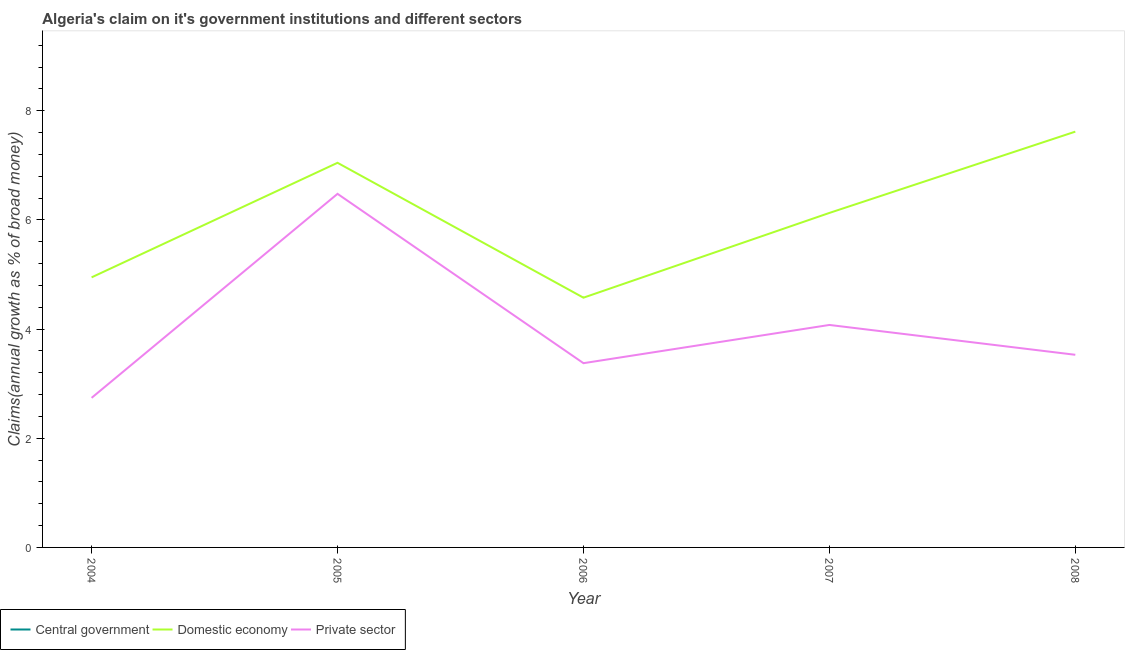How many different coloured lines are there?
Your answer should be very brief. 2. What is the percentage of claim on the domestic economy in 2008?
Offer a terse response. 7.62. Across all years, what is the maximum percentage of claim on the domestic economy?
Your answer should be compact. 7.62. Across all years, what is the minimum percentage of claim on the private sector?
Your answer should be very brief. 2.74. What is the total percentage of claim on the central government in the graph?
Ensure brevity in your answer.  0. What is the difference between the percentage of claim on the private sector in 2006 and that in 2008?
Give a very brief answer. -0.15. What is the difference between the percentage of claim on the central government in 2004 and the percentage of claim on the domestic economy in 2005?
Your response must be concise. -7.05. What is the average percentage of claim on the private sector per year?
Make the answer very short. 4.04. In the year 2007, what is the difference between the percentage of claim on the private sector and percentage of claim on the domestic economy?
Your answer should be very brief. -2.05. In how many years, is the percentage of claim on the domestic economy greater than 6 %?
Your response must be concise. 3. What is the ratio of the percentage of claim on the private sector in 2004 to that in 2005?
Offer a very short reply. 0.42. What is the difference between the highest and the second highest percentage of claim on the domestic economy?
Provide a short and direct response. 0.57. What is the difference between the highest and the lowest percentage of claim on the private sector?
Offer a very short reply. 3.74. In how many years, is the percentage of claim on the private sector greater than the average percentage of claim on the private sector taken over all years?
Make the answer very short. 2. Is the sum of the percentage of claim on the private sector in 2006 and 2008 greater than the maximum percentage of claim on the domestic economy across all years?
Provide a short and direct response. No. Is it the case that in every year, the sum of the percentage of claim on the central government and percentage of claim on the domestic economy is greater than the percentage of claim on the private sector?
Give a very brief answer. Yes. Is the percentage of claim on the domestic economy strictly greater than the percentage of claim on the private sector over the years?
Give a very brief answer. Yes. Are the values on the major ticks of Y-axis written in scientific E-notation?
Offer a terse response. No. Does the graph contain any zero values?
Provide a succinct answer. Yes. Where does the legend appear in the graph?
Offer a very short reply. Bottom left. How many legend labels are there?
Your response must be concise. 3. What is the title of the graph?
Your answer should be very brief. Algeria's claim on it's government institutions and different sectors. Does "Taxes" appear as one of the legend labels in the graph?
Provide a succinct answer. No. What is the label or title of the X-axis?
Provide a short and direct response. Year. What is the label or title of the Y-axis?
Provide a short and direct response. Claims(annual growth as % of broad money). What is the Claims(annual growth as % of broad money) in Domestic economy in 2004?
Ensure brevity in your answer.  4.95. What is the Claims(annual growth as % of broad money) of Private sector in 2004?
Provide a short and direct response. 2.74. What is the Claims(annual growth as % of broad money) in Central government in 2005?
Your response must be concise. 0. What is the Claims(annual growth as % of broad money) of Domestic economy in 2005?
Your response must be concise. 7.05. What is the Claims(annual growth as % of broad money) of Private sector in 2005?
Your answer should be very brief. 6.48. What is the Claims(annual growth as % of broad money) of Domestic economy in 2006?
Offer a very short reply. 4.58. What is the Claims(annual growth as % of broad money) in Private sector in 2006?
Make the answer very short. 3.38. What is the Claims(annual growth as % of broad money) of Central government in 2007?
Give a very brief answer. 0. What is the Claims(annual growth as % of broad money) in Domestic economy in 2007?
Your answer should be very brief. 6.13. What is the Claims(annual growth as % of broad money) of Private sector in 2007?
Your answer should be very brief. 4.08. What is the Claims(annual growth as % of broad money) in Domestic economy in 2008?
Your answer should be very brief. 7.62. What is the Claims(annual growth as % of broad money) of Private sector in 2008?
Offer a very short reply. 3.53. Across all years, what is the maximum Claims(annual growth as % of broad money) in Domestic economy?
Your response must be concise. 7.62. Across all years, what is the maximum Claims(annual growth as % of broad money) in Private sector?
Give a very brief answer. 6.48. Across all years, what is the minimum Claims(annual growth as % of broad money) in Domestic economy?
Your response must be concise. 4.58. Across all years, what is the minimum Claims(annual growth as % of broad money) in Private sector?
Provide a short and direct response. 2.74. What is the total Claims(annual growth as % of broad money) in Domestic economy in the graph?
Keep it short and to the point. 30.31. What is the total Claims(annual growth as % of broad money) of Private sector in the graph?
Keep it short and to the point. 20.2. What is the difference between the Claims(annual growth as % of broad money) of Domestic economy in 2004 and that in 2005?
Give a very brief answer. -2.1. What is the difference between the Claims(annual growth as % of broad money) of Private sector in 2004 and that in 2005?
Provide a short and direct response. -3.74. What is the difference between the Claims(annual growth as % of broad money) of Domestic economy in 2004 and that in 2006?
Keep it short and to the point. 0.37. What is the difference between the Claims(annual growth as % of broad money) of Private sector in 2004 and that in 2006?
Your answer should be very brief. -0.64. What is the difference between the Claims(annual growth as % of broad money) in Domestic economy in 2004 and that in 2007?
Provide a succinct answer. -1.18. What is the difference between the Claims(annual growth as % of broad money) in Private sector in 2004 and that in 2007?
Give a very brief answer. -1.34. What is the difference between the Claims(annual growth as % of broad money) in Domestic economy in 2004 and that in 2008?
Ensure brevity in your answer.  -2.67. What is the difference between the Claims(annual growth as % of broad money) of Private sector in 2004 and that in 2008?
Offer a terse response. -0.79. What is the difference between the Claims(annual growth as % of broad money) in Domestic economy in 2005 and that in 2006?
Provide a succinct answer. 2.47. What is the difference between the Claims(annual growth as % of broad money) of Private sector in 2005 and that in 2006?
Your answer should be compact. 3.1. What is the difference between the Claims(annual growth as % of broad money) in Domestic economy in 2005 and that in 2007?
Provide a succinct answer. 0.92. What is the difference between the Claims(annual growth as % of broad money) in Private sector in 2005 and that in 2007?
Offer a very short reply. 2.4. What is the difference between the Claims(annual growth as % of broad money) of Domestic economy in 2005 and that in 2008?
Your answer should be very brief. -0.57. What is the difference between the Claims(annual growth as % of broad money) in Private sector in 2005 and that in 2008?
Provide a short and direct response. 2.95. What is the difference between the Claims(annual growth as % of broad money) of Domestic economy in 2006 and that in 2007?
Offer a very short reply. -1.55. What is the difference between the Claims(annual growth as % of broad money) in Private sector in 2006 and that in 2007?
Ensure brevity in your answer.  -0.7. What is the difference between the Claims(annual growth as % of broad money) in Domestic economy in 2006 and that in 2008?
Provide a short and direct response. -3.04. What is the difference between the Claims(annual growth as % of broad money) of Private sector in 2006 and that in 2008?
Your answer should be very brief. -0.15. What is the difference between the Claims(annual growth as % of broad money) of Domestic economy in 2007 and that in 2008?
Your answer should be compact. -1.49. What is the difference between the Claims(annual growth as % of broad money) of Private sector in 2007 and that in 2008?
Your answer should be very brief. 0.55. What is the difference between the Claims(annual growth as % of broad money) in Domestic economy in 2004 and the Claims(annual growth as % of broad money) in Private sector in 2005?
Provide a short and direct response. -1.53. What is the difference between the Claims(annual growth as % of broad money) of Domestic economy in 2004 and the Claims(annual growth as % of broad money) of Private sector in 2006?
Keep it short and to the point. 1.57. What is the difference between the Claims(annual growth as % of broad money) in Domestic economy in 2004 and the Claims(annual growth as % of broad money) in Private sector in 2007?
Ensure brevity in your answer.  0.87. What is the difference between the Claims(annual growth as % of broad money) in Domestic economy in 2004 and the Claims(annual growth as % of broad money) in Private sector in 2008?
Offer a terse response. 1.42. What is the difference between the Claims(annual growth as % of broad money) of Domestic economy in 2005 and the Claims(annual growth as % of broad money) of Private sector in 2006?
Give a very brief answer. 3.67. What is the difference between the Claims(annual growth as % of broad money) in Domestic economy in 2005 and the Claims(annual growth as % of broad money) in Private sector in 2007?
Your answer should be compact. 2.97. What is the difference between the Claims(annual growth as % of broad money) in Domestic economy in 2005 and the Claims(annual growth as % of broad money) in Private sector in 2008?
Offer a very short reply. 3.52. What is the difference between the Claims(annual growth as % of broad money) in Domestic economy in 2006 and the Claims(annual growth as % of broad money) in Private sector in 2007?
Offer a terse response. 0.5. What is the difference between the Claims(annual growth as % of broad money) in Domestic economy in 2006 and the Claims(annual growth as % of broad money) in Private sector in 2008?
Keep it short and to the point. 1.05. What is the difference between the Claims(annual growth as % of broad money) in Domestic economy in 2007 and the Claims(annual growth as % of broad money) in Private sector in 2008?
Provide a succinct answer. 2.6. What is the average Claims(annual growth as % of broad money) in Domestic economy per year?
Offer a terse response. 6.06. What is the average Claims(annual growth as % of broad money) in Private sector per year?
Your answer should be compact. 4.04. In the year 2004, what is the difference between the Claims(annual growth as % of broad money) in Domestic economy and Claims(annual growth as % of broad money) in Private sector?
Offer a very short reply. 2.21. In the year 2005, what is the difference between the Claims(annual growth as % of broad money) in Domestic economy and Claims(annual growth as % of broad money) in Private sector?
Your answer should be compact. 0.57. In the year 2006, what is the difference between the Claims(annual growth as % of broad money) in Domestic economy and Claims(annual growth as % of broad money) in Private sector?
Offer a terse response. 1.2. In the year 2007, what is the difference between the Claims(annual growth as % of broad money) in Domestic economy and Claims(annual growth as % of broad money) in Private sector?
Your response must be concise. 2.05. In the year 2008, what is the difference between the Claims(annual growth as % of broad money) in Domestic economy and Claims(annual growth as % of broad money) in Private sector?
Your response must be concise. 4.09. What is the ratio of the Claims(annual growth as % of broad money) of Domestic economy in 2004 to that in 2005?
Make the answer very short. 0.7. What is the ratio of the Claims(annual growth as % of broad money) in Private sector in 2004 to that in 2005?
Ensure brevity in your answer.  0.42. What is the ratio of the Claims(annual growth as % of broad money) in Domestic economy in 2004 to that in 2006?
Your response must be concise. 1.08. What is the ratio of the Claims(annual growth as % of broad money) of Private sector in 2004 to that in 2006?
Give a very brief answer. 0.81. What is the ratio of the Claims(annual growth as % of broad money) of Domestic economy in 2004 to that in 2007?
Give a very brief answer. 0.81. What is the ratio of the Claims(annual growth as % of broad money) in Private sector in 2004 to that in 2007?
Give a very brief answer. 0.67. What is the ratio of the Claims(annual growth as % of broad money) in Domestic economy in 2004 to that in 2008?
Provide a succinct answer. 0.65. What is the ratio of the Claims(annual growth as % of broad money) in Private sector in 2004 to that in 2008?
Your response must be concise. 0.78. What is the ratio of the Claims(annual growth as % of broad money) in Domestic economy in 2005 to that in 2006?
Offer a terse response. 1.54. What is the ratio of the Claims(annual growth as % of broad money) of Private sector in 2005 to that in 2006?
Give a very brief answer. 1.92. What is the ratio of the Claims(annual growth as % of broad money) in Domestic economy in 2005 to that in 2007?
Offer a terse response. 1.15. What is the ratio of the Claims(annual growth as % of broad money) in Private sector in 2005 to that in 2007?
Offer a terse response. 1.59. What is the ratio of the Claims(annual growth as % of broad money) of Domestic economy in 2005 to that in 2008?
Give a very brief answer. 0.93. What is the ratio of the Claims(annual growth as % of broad money) in Private sector in 2005 to that in 2008?
Offer a very short reply. 1.84. What is the ratio of the Claims(annual growth as % of broad money) in Domestic economy in 2006 to that in 2007?
Make the answer very short. 0.75. What is the ratio of the Claims(annual growth as % of broad money) in Private sector in 2006 to that in 2007?
Provide a succinct answer. 0.83. What is the ratio of the Claims(annual growth as % of broad money) of Domestic economy in 2006 to that in 2008?
Keep it short and to the point. 0.6. What is the ratio of the Claims(annual growth as % of broad money) of Private sector in 2006 to that in 2008?
Provide a succinct answer. 0.96. What is the ratio of the Claims(annual growth as % of broad money) in Domestic economy in 2007 to that in 2008?
Your answer should be compact. 0.8. What is the ratio of the Claims(annual growth as % of broad money) in Private sector in 2007 to that in 2008?
Offer a terse response. 1.15. What is the difference between the highest and the second highest Claims(annual growth as % of broad money) in Domestic economy?
Provide a succinct answer. 0.57. What is the difference between the highest and the second highest Claims(annual growth as % of broad money) of Private sector?
Keep it short and to the point. 2.4. What is the difference between the highest and the lowest Claims(annual growth as % of broad money) of Domestic economy?
Ensure brevity in your answer.  3.04. What is the difference between the highest and the lowest Claims(annual growth as % of broad money) in Private sector?
Your response must be concise. 3.74. 